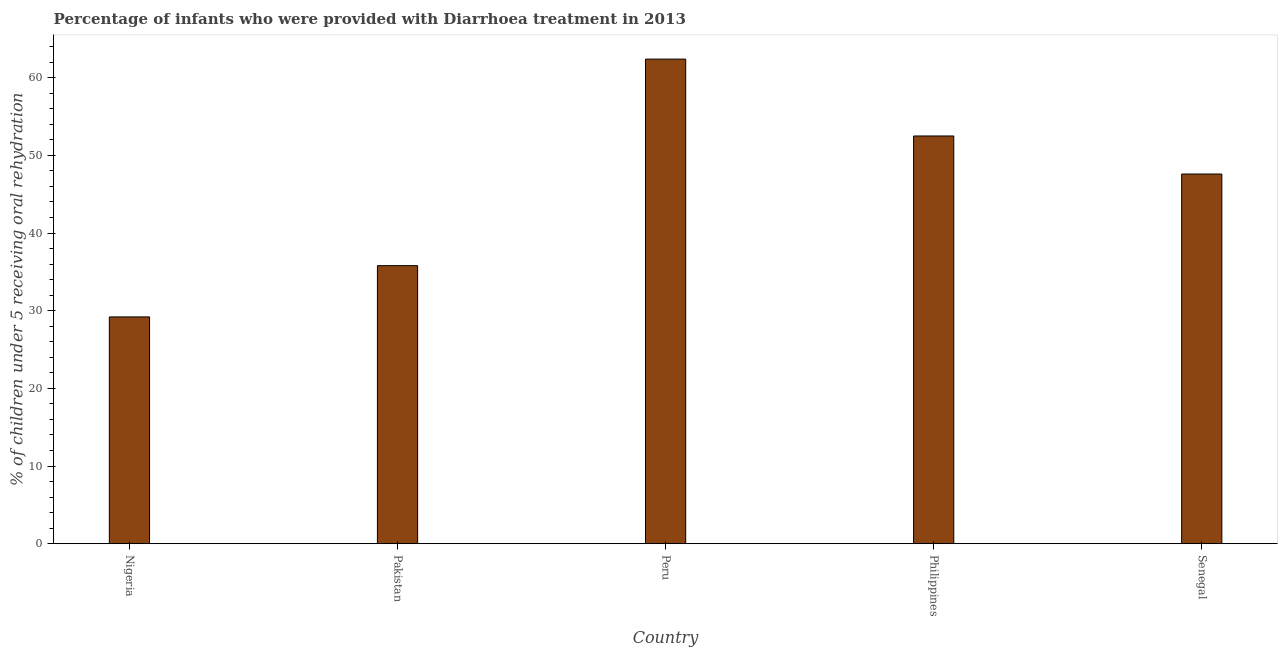Does the graph contain any zero values?
Ensure brevity in your answer.  No. What is the title of the graph?
Offer a terse response. Percentage of infants who were provided with Diarrhoea treatment in 2013. What is the label or title of the X-axis?
Provide a succinct answer. Country. What is the label or title of the Y-axis?
Keep it short and to the point. % of children under 5 receiving oral rehydration. What is the percentage of children who were provided with treatment diarrhoea in Peru?
Give a very brief answer. 62.4. Across all countries, what is the maximum percentage of children who were provided with treatment diarrhoea?
Give a very brief answer. 62.4. Across all countries, what is the minimum percentage of children who were provided with treatment diarrhoea?
Ensure brevity in your answer.  29.2. In which country was the percentage of children who were provided with treatment diarrhoea minimum?
Provide a succinct answer. Nigeria. What is the sum of the percentage of children who were provided with treatment diarrhoea?
Give a very brief answer. 227.5. What is the difference between the percentage of children who were provided with treatment diarrhoea in Pakistan and Senegal?
Give a very brief answer. -11.8. What is the average percentage of children who were provided with treatment diarrhoea per country?
Ensure brevity in your answer.  45.5. What is the median percentage of children who were provided with treatment diarrhoea?
Provide a succinct answer. 47.6. What is the ratio of the percentage of children who were provided with treatment diarrhoea in Nigeria to that in Philippines?
Offer a very short reply. 0.56. Is the percentage of children who were provided with treatment diarrhoea in Pakistan less than that in Philippines?
Your answer should be very brief. Yes. Is the difference between the percentage of children who were provided with treatment diarrhoea in Nigeria and Senegal greater than the difference between any two countries?
Offer a terse response. No. What is the difference between the highest and the second highest percentage of children who were provided with treatment diarrhoea?
Keep it short and to the point. 9.9. What is the difference between the highest and the lowest percentage of children who were provided with treatment diarrhoea?
Offer a very short reply. 33.2. In how many countries, is the percentage of children who were provided with treatment diarrhoea greater than the average percentage of children who were provided with treatment diarrhoea taken over all countries?
Provide a short and direct response. 3. What is the % of children under 5 receiving oral rehydration in Nigeria?
Your answer should be very brief. 29.2. What is the % of children under 5 receiving oral rehydration in Pakistan?
Ensure brevity in your answer.  35.8. What is the % of children under 5 receiving oral rehydration in Peru?
Your response must be concise. 62.4. What is the % of children under 5 receiving oral rehydration of Philippines?
Your response must be concise. 52.5. What is the % of children under 5 receiving oral rehydration in Senegal?
Offer a very short reply. 47.6. What is the difference between the % of children under 5 receiving oral rehydration in Nigeria and Pakistan?
Your answer should be very brief. -6.6. What is the difference between the % of children under 5 receiving oral rehydration in Nigeria and Peru?
Your answer should be compact. -33.2. What is the difference between the % of children under 5 receiving oral rehydration in Nigeria and Philippines?
Your answer should be compact. -23.3. What is the difference between the % of children under 5 receiving oral rehydration in Nigeria and Senegal?
Keep it short and to the point. -18.4. What is the difference between the % of children under 5 receiving oral rehydration in Pakistan and Peru?
Your answer should be very brief. -26.6. What is the difference between the % of children under 5 receiving oral rehydration in Pakistan and Philippines?
Offer a terse response. -16.7. What is the difference between the % of children under 5 receiving oral rehydration in Peru and Philippines?
Provide a succinct answer. 9.9. What is the difference between the % of children under 5 receiving oral rehydration in Peru and Senegal?
Provide a succinct answer. 14.8. What is the difference between the % of children under 5 receiving oral rehydration in Philippines and Senegal?
Offer a terse response. 4.9. What is the ratio of the % of children under 5 receiving oral rehydration in Nigeria to that in Pakistan?
Give a very brief answer. 0.82. What is the ratio of the % of children under 5 receiving oral rehydration in Nigeria to that in Peru?
Your answer should be very brief. 0.47. What is the ratio of the % of children under 5 receiving oral rehydration in Nigeria to that in Philippines?
Offer a terse response. 0.56. What is the ratio of the % of children under 5 receiving oral rehydration in Nigeria to that in Senegal?
Your answer should be very brief. 0.61. What is the ratio of the % of children under 5 receiving oral rehydration in Pakistan to that in Peru?
Offer a terse response. 0.57. What is the ratio of the % of children under 5 receiving oral rehydration in Pakistan to that in Philippines?
Make the answer very short. 0.68. What is the ratio of the % of children under 5 receiving oral rehydration in Pakistan to that in Senegal?
Ensure brevity in your answer.  0.75. What is the ratio of the % of children under 5 receiving oral rehydration in Peru to that in Philippines?
Provide a succinct answer. 1.19. What is the ratio of the % of children under 5 receiving oral rehydration in Peru to that in Senegal?
Provide a succinct answer. 1.31. What is the ratio of the % of children under 5 receiving oral rehydration in Philippines to that in Senegal?
Provide a succinct answer. 1.1. 